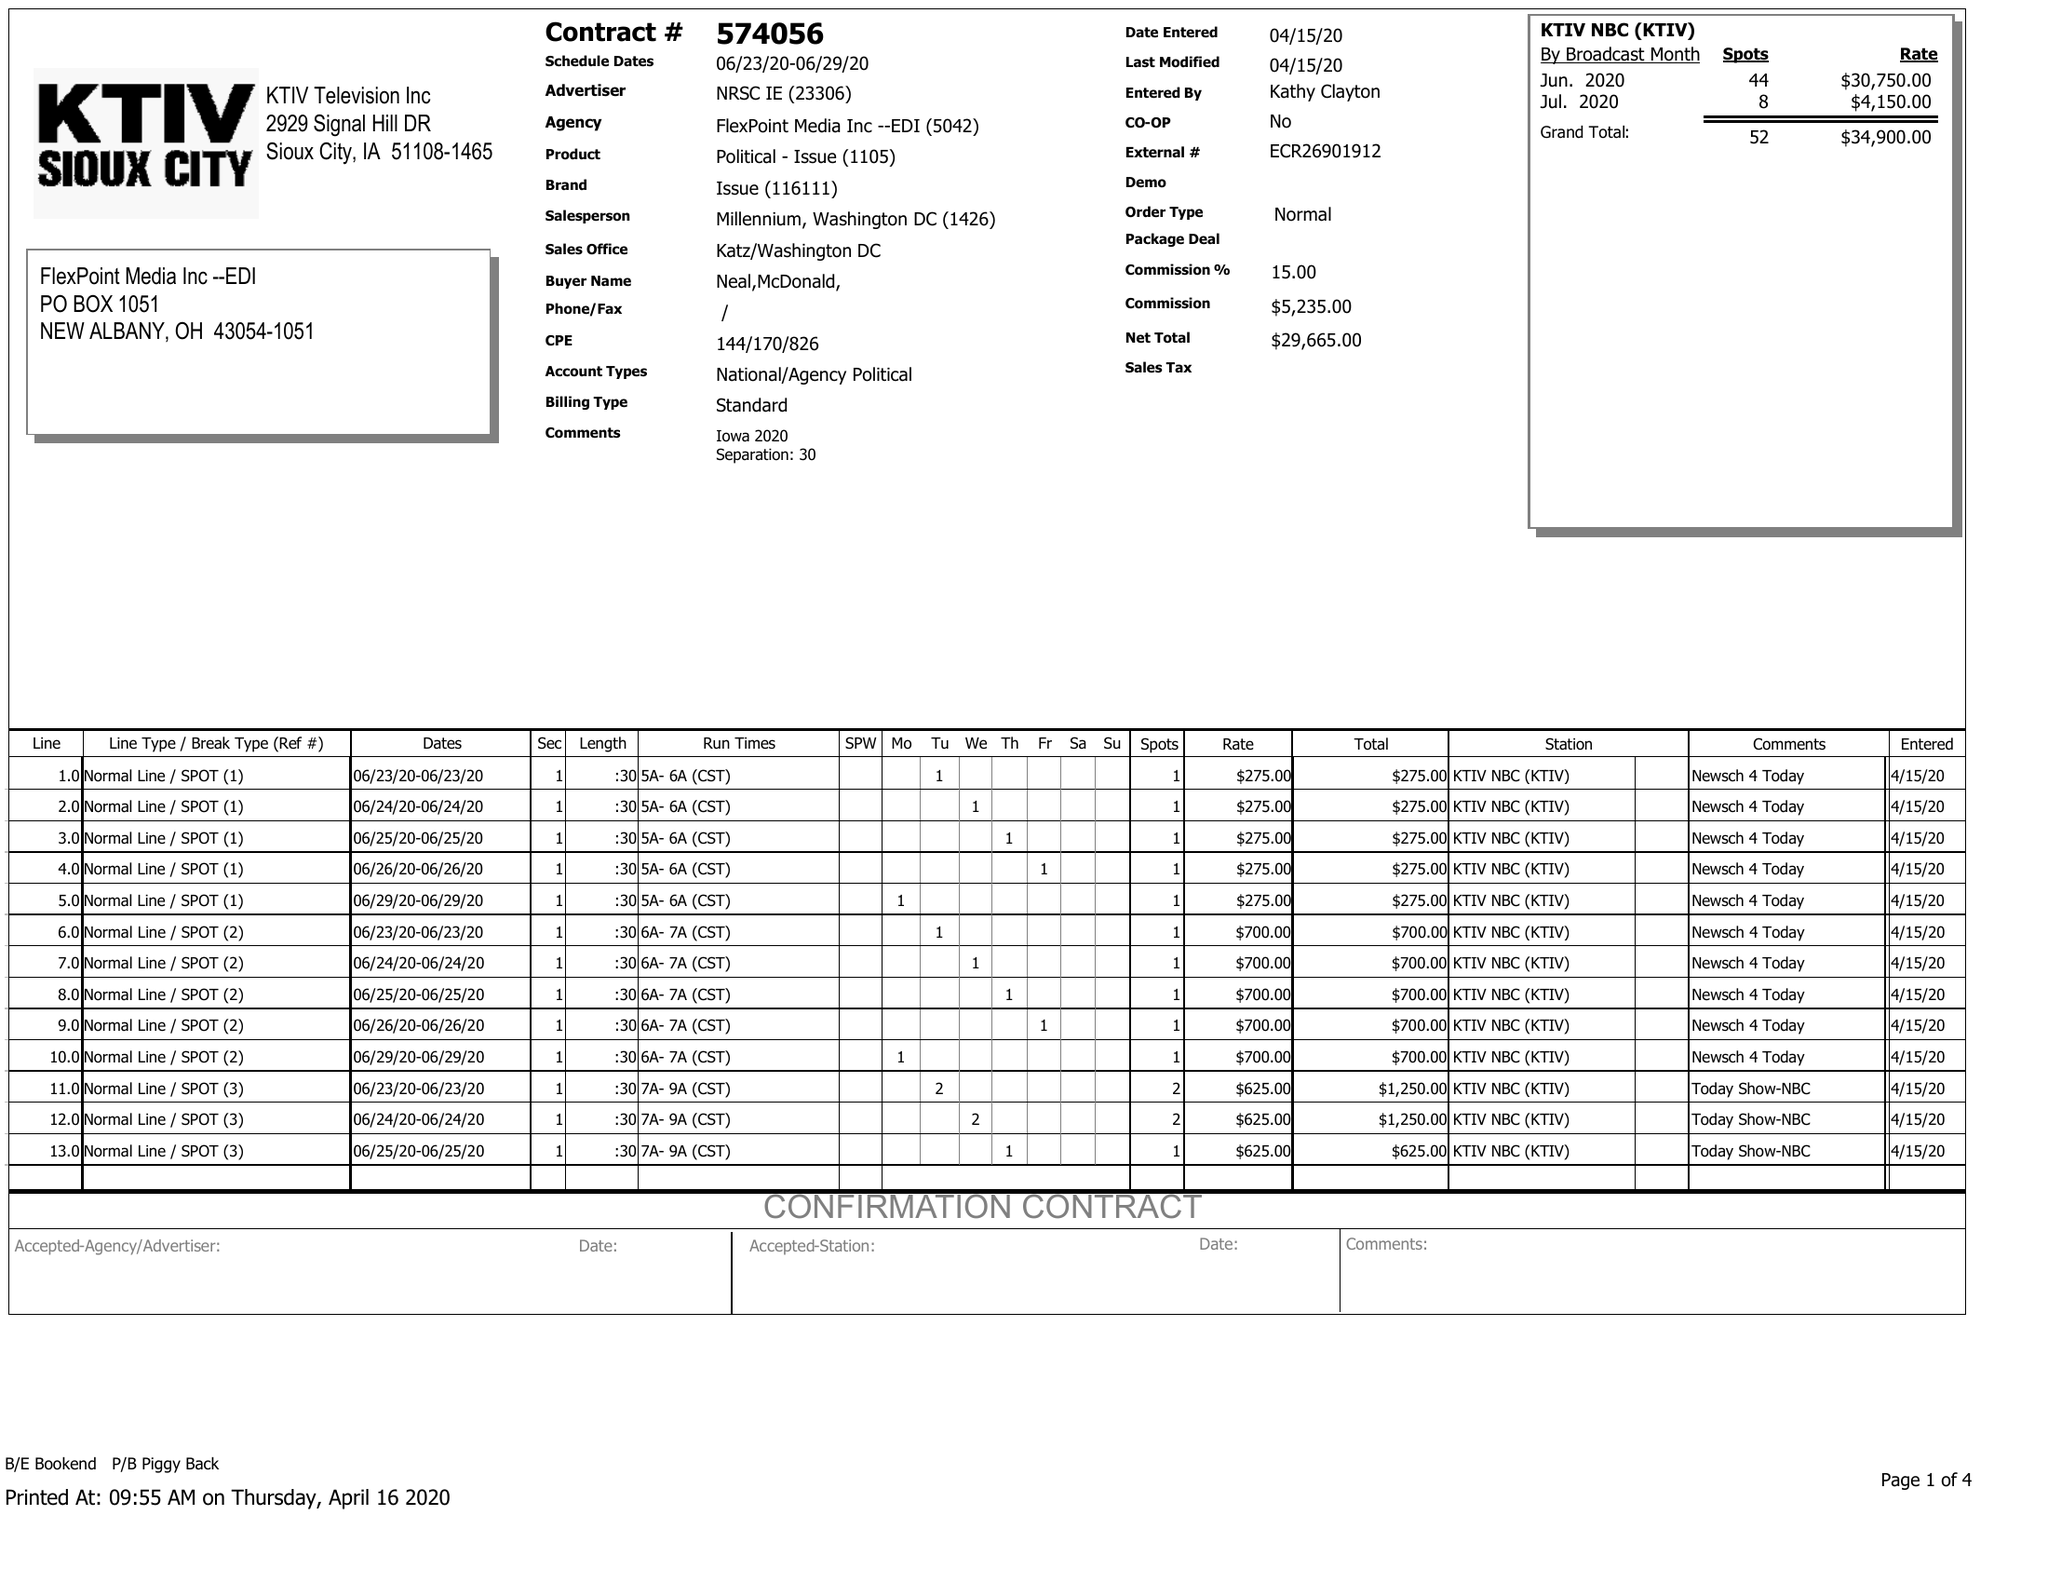What is the value for the flight_to?
Answer the question using a single word or phrase. 06/29/20 